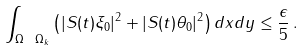Convert formula to latex. <formula><loc_0><loc_0><loc_500><loc_500>\int _ { \Omega \ \Omega _ { k } } \left ( | S ( t ) \xi _ { 0 } | ^ { 2 } + | S ( t ) \theta _ { 0 } | ^ { 2 } \right ) d x d y \leq \frac { \epsilon } { 5 } \, .</formula> 